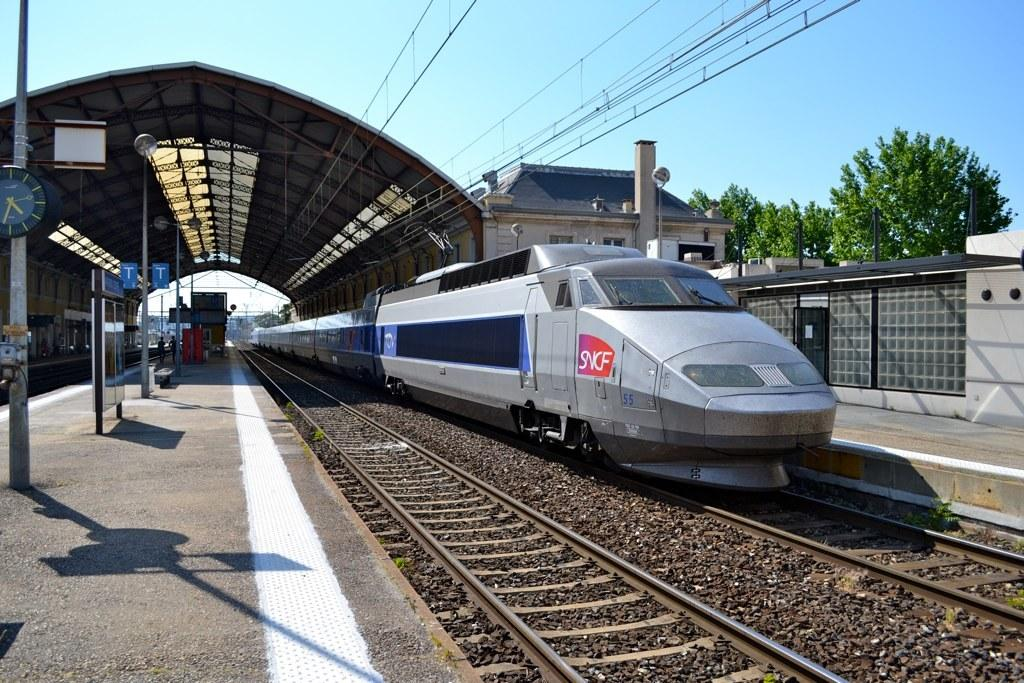<image>
Write a terse but informative summary of the picture. A bullet type train that says SNCF  and the number 55 on it. 